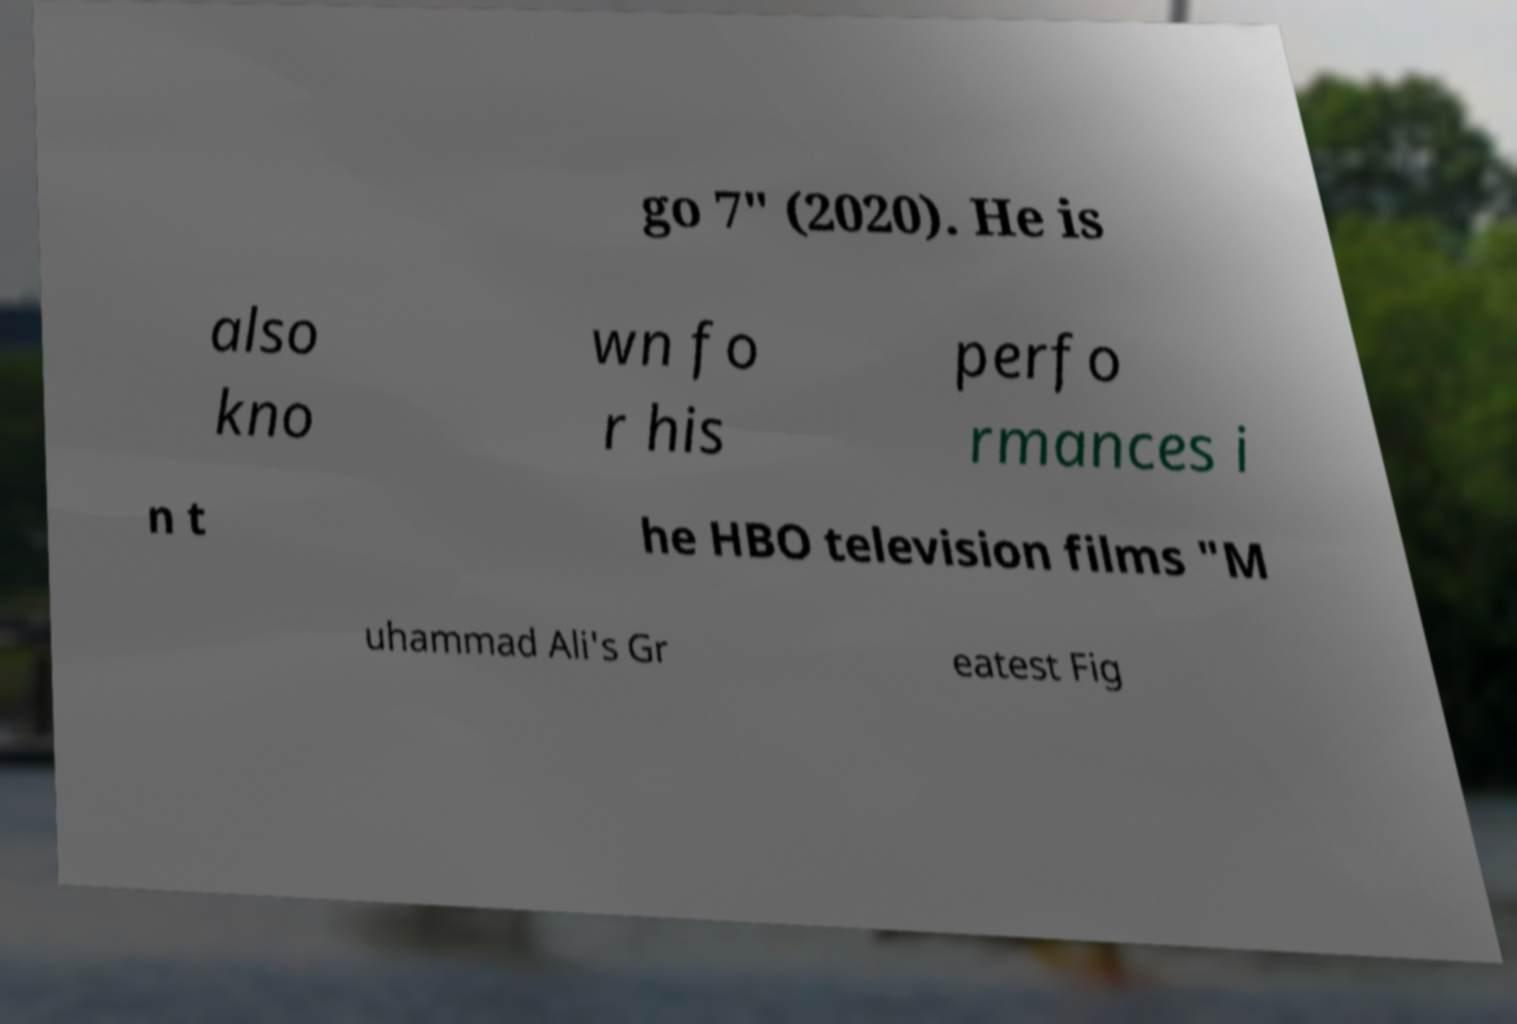Can you accurately transcribe the text from the provided image for me? go 7" (2020). He is also kno wn fo r his perfo rmances i n t he HBO television films "M uhammad Ali's Gr eatest Fig 